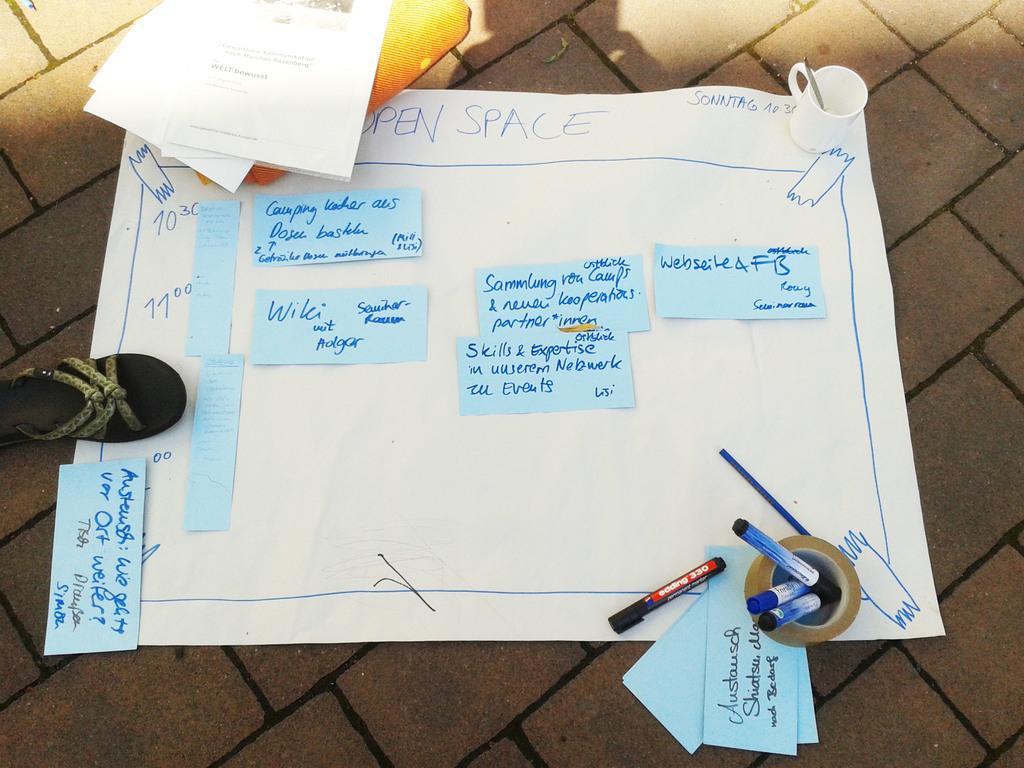Could you give a brief overview of what you see in this image? In this picture I can see in the middle there is a chart, on the left side there is a chappal. On the right side there are markers and a tape, at the top there is a cup. 